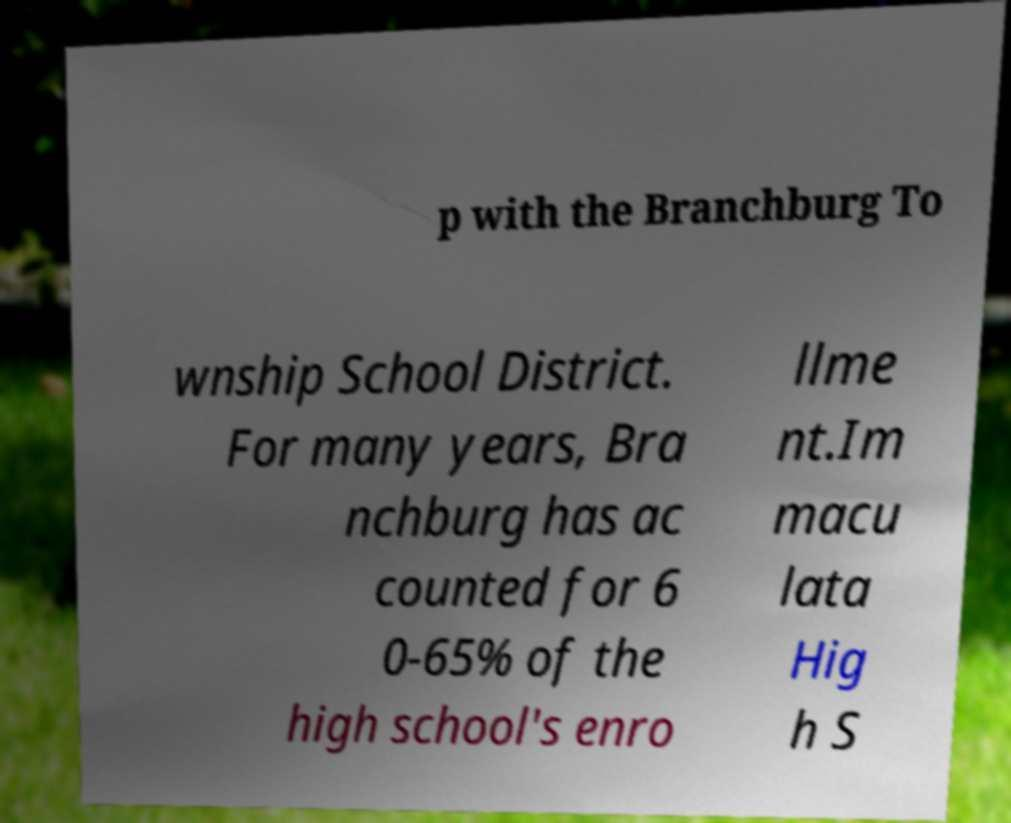Please identify and transcribe the text found in this image. p with the Branchburg To wnship School District. For many years, Bra nchburg has ac counted for 6 0-65% of the high school's enro llme nt.Im macu lata Hig h S 